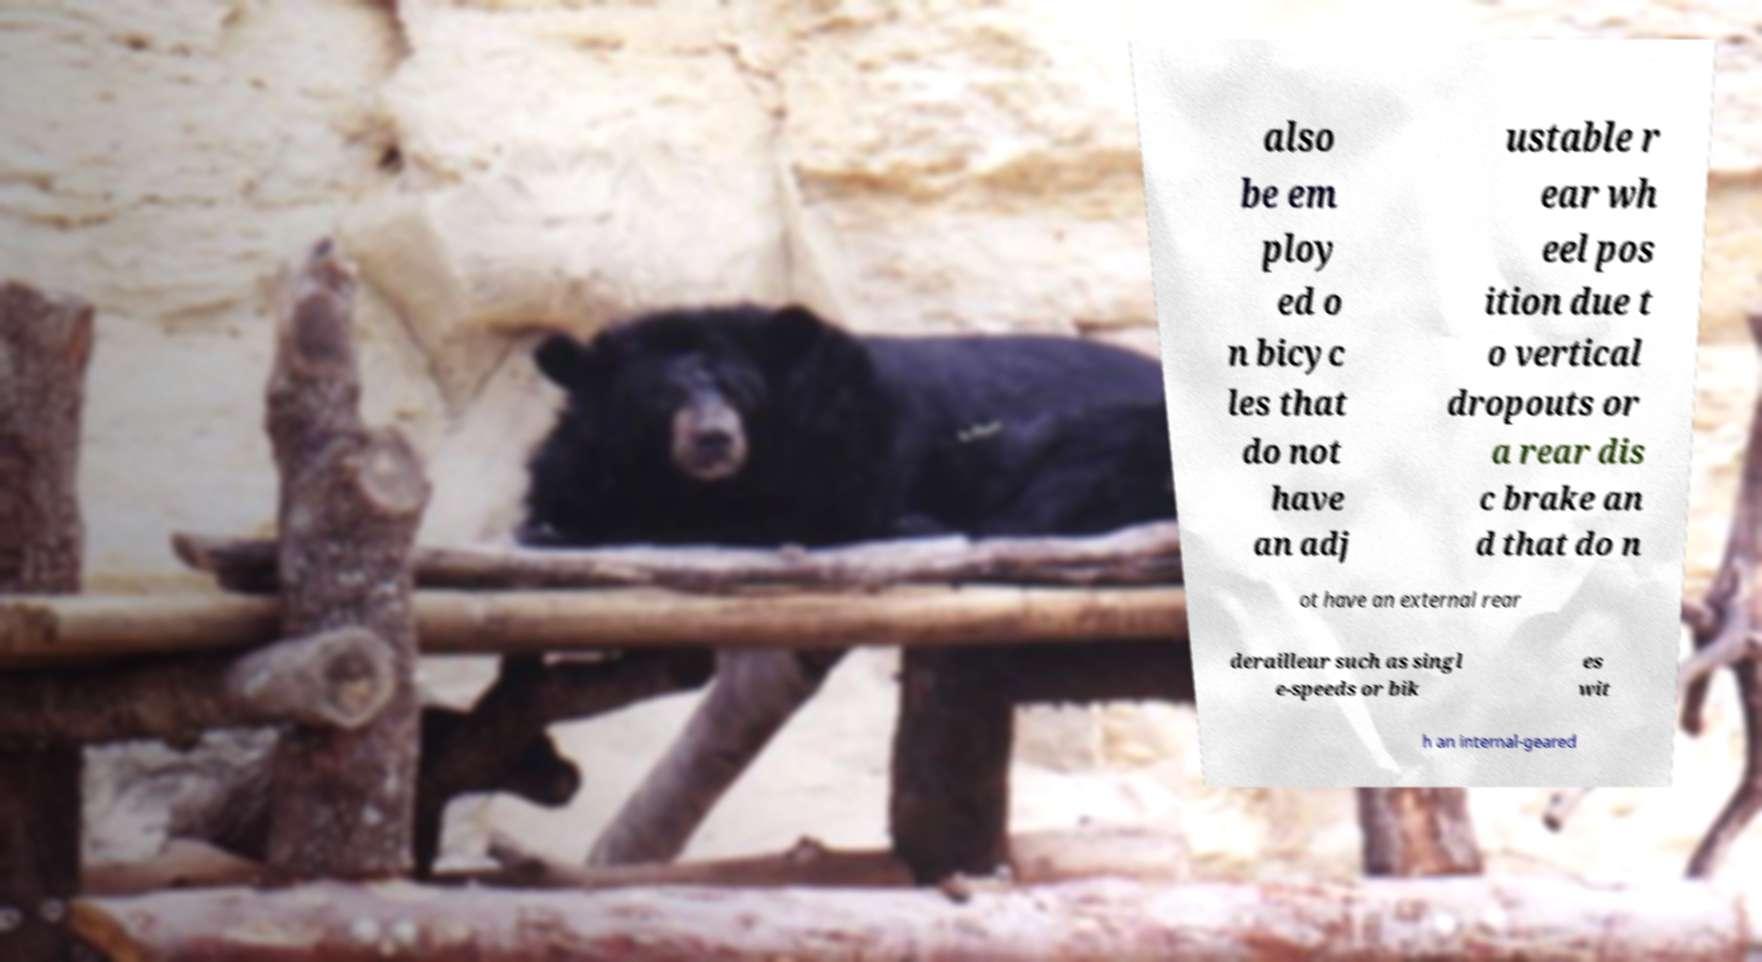Can you accurately transcribe the text from the provided image for me? also be em ploy ed o n bicyc les that do not have an adj ustable r ear wh eel pos ition due t o vertical dropouts or a rear dis c brake an d that do n ot have an external rear derailleur such as singl e-speeds or bik es wit h an internal-geared 